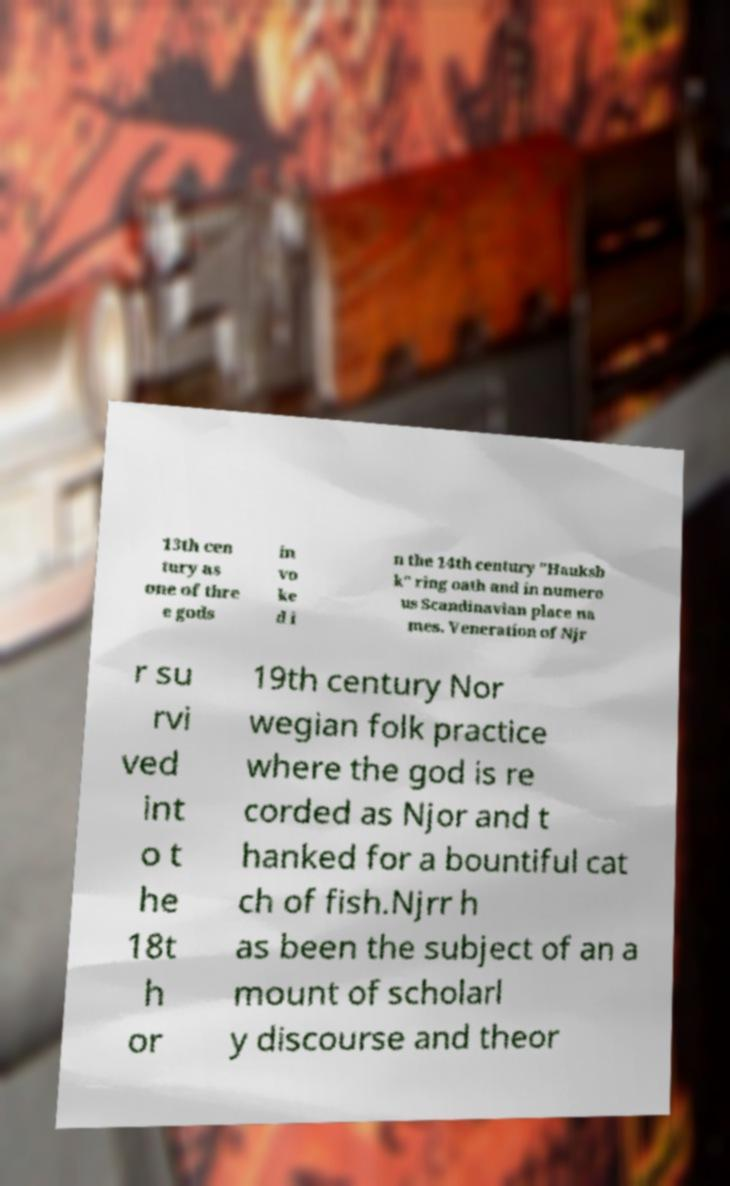What messages or text are displayed in this image? I need them in a readable, typed format. 13th cen tury as one of thre e gods in vo ke d i n the 14th century "Hauksb k" ring oath and in numero us Scandinavian place na mes. Veneration of Njr r su rvi ved int o t he 18t h or 19th century Nor wegian folk practice where the god is re corded as Njor and t hanked for a bountiful cat ch of fish.Njrr h as been the subject of an a mount of scholarl y discourse and theor 